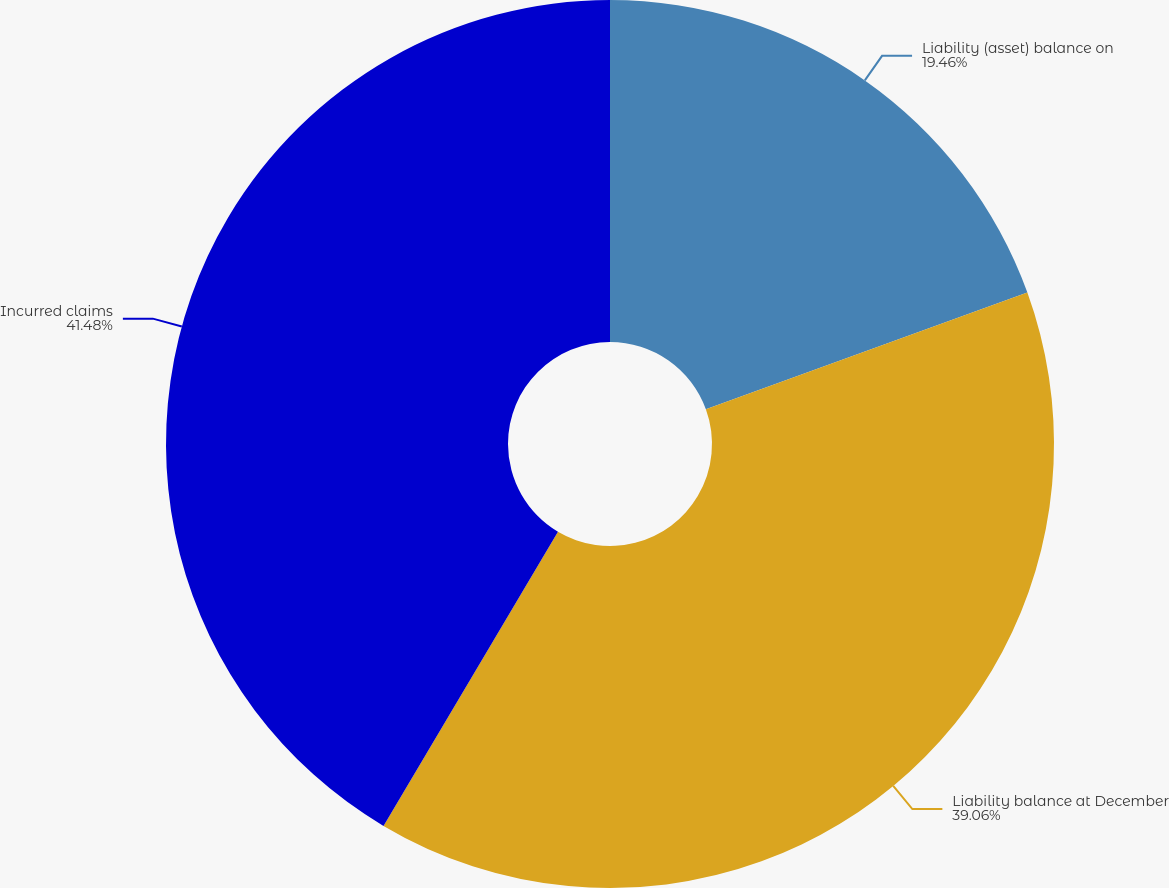<chart> <loc_0><loc_0><loc_500><loc_500><pie_chart><fcel>Liability (asset) balance on<fcel>Liability balance at December<fcel>Incurred claims<nl><fcel>19.46%<fcel>39.06%<fcel>41.48%<nl></chart> 